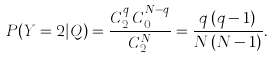<formula> <loc_0><loc_0><loc_500><loc_500>P ( Y = 2 | Q ) = \frac { C _ { 2 } ^ { q } \, C _ { 0 } ^ { N - q } } { C _ { 2 } ^ { N } } = \frac { q \, ( q - 1 ) } { N \, ( N - 1 ) } .</formula> 